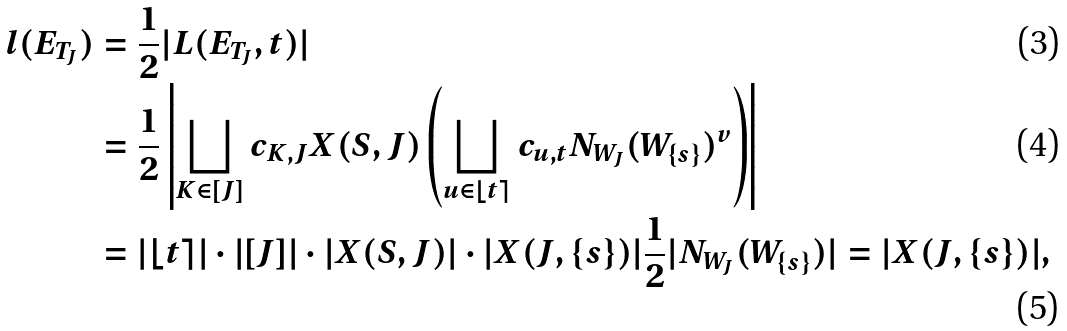Convert formula to latex. <formula><loc_0><loc_0><loc_500><loc_500>l ( E _ { T _ { J } } ) & = \frac { 1 } { 2 } | L ( E _ { T _ { J } } , t ) | \\ & = \frac { 1 } { 2 } \left | \bigsqcup _ { K \in [ J ] } c _ { K , J } X ( S , J ) \left ( \bigsqcup _ { u \in \lfloor t \rceil } c _ { u , t } N _ { W _ { J } } ( W _ { \{ s \} } ) ^ { v } \right ) \right | \\ & = | \lfloor t \rceil | \cdot | [ J ] | \cdot | X ( S , J ) | \cdot | X ( J , \{ s \} ) | \frac { 1 } { 2 } | N _ { W _ { J } } ( W _ { \{ s \} } ) | = | X ( J , \{ s \} ) | ,</formula> 